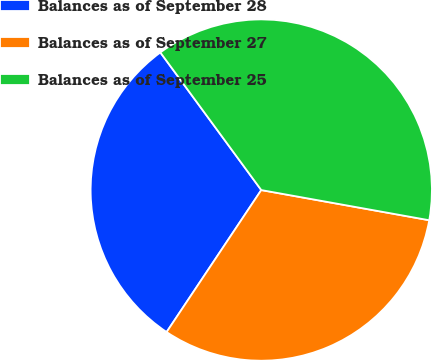<chart> <loc_0><loc_0><loc_500><loc_500><pie_chart><fcel>Balances as of September 28<fcel>Balances as of September 27<fcel>Balances as of September 25<nl><fcel>30.57%<fcel>31.53%<fcel>37.9%<nl></chart> 